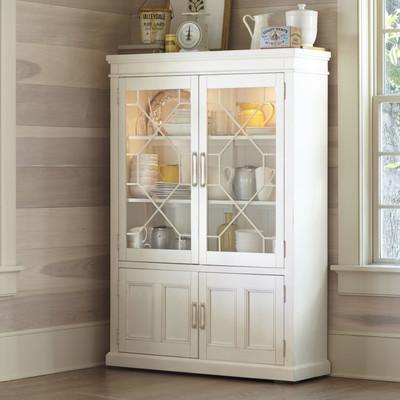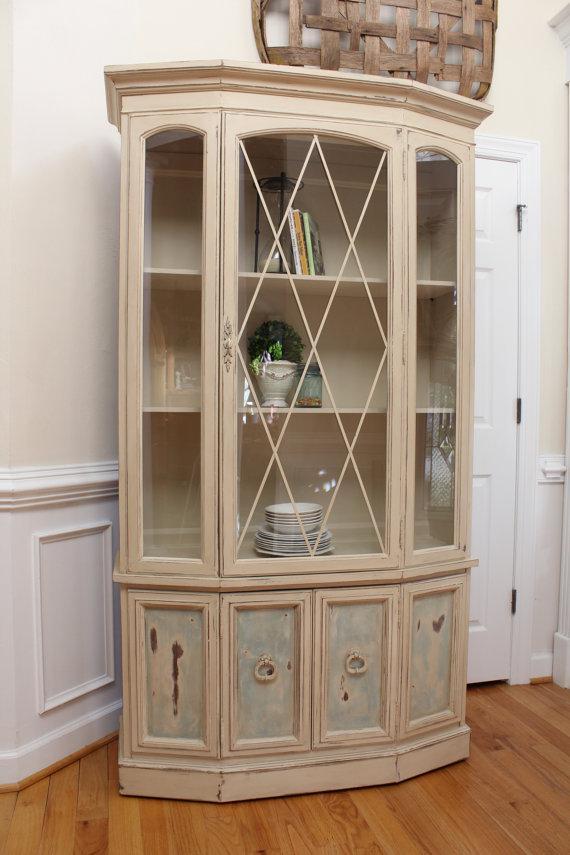The first image is the image on the left, the second image is the image on the right. Given the left and right images, does the statement "One cabinet has a white exterior and a front that is not flat, with curving drawers under the display hutch top." hold true? Answer yes or no. No. The first image is the image on the left, the second image is the image on the right. Analyze the images presented: Is the assertion "The cabinet in the image on the right is not a square shape." valid? Answer yes or no. Yes. 